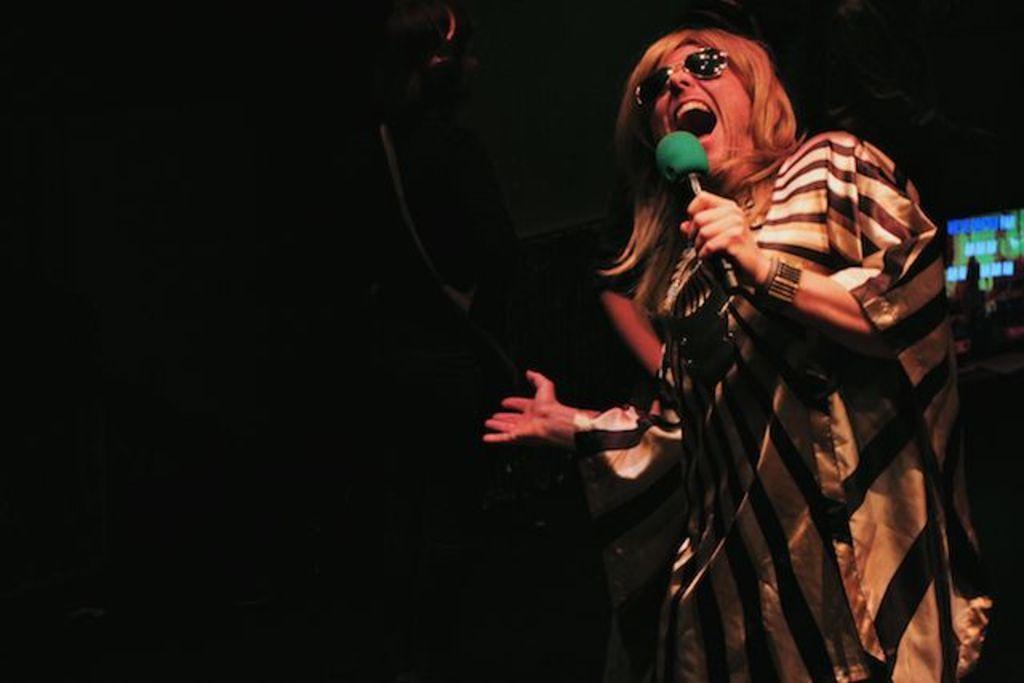How would you summarize this image in a sentence or two? In this image I can see one person is standing and I can see this person is holding a mic. I can also see this person is wearing golden color dress and black shades. I can also see this image is in dark. 